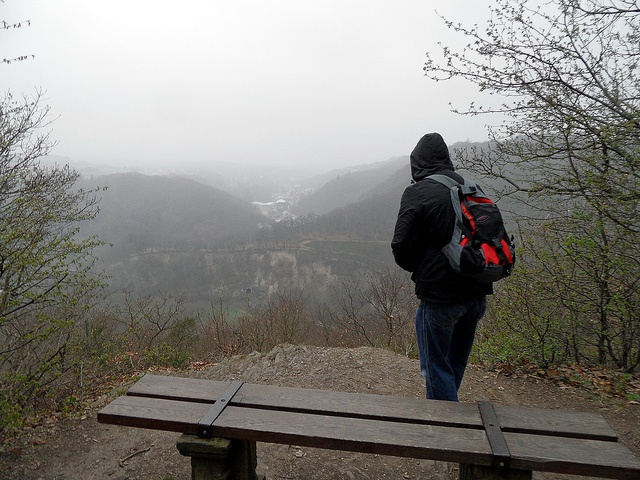Describe the objects in this image and their specific colors. I can see bench in lightgray, gray, and black tones, people in lightgray, black, gray, and brown tones, and backpack in lightgray, black, gray, brown, and maroon tones in this image. 